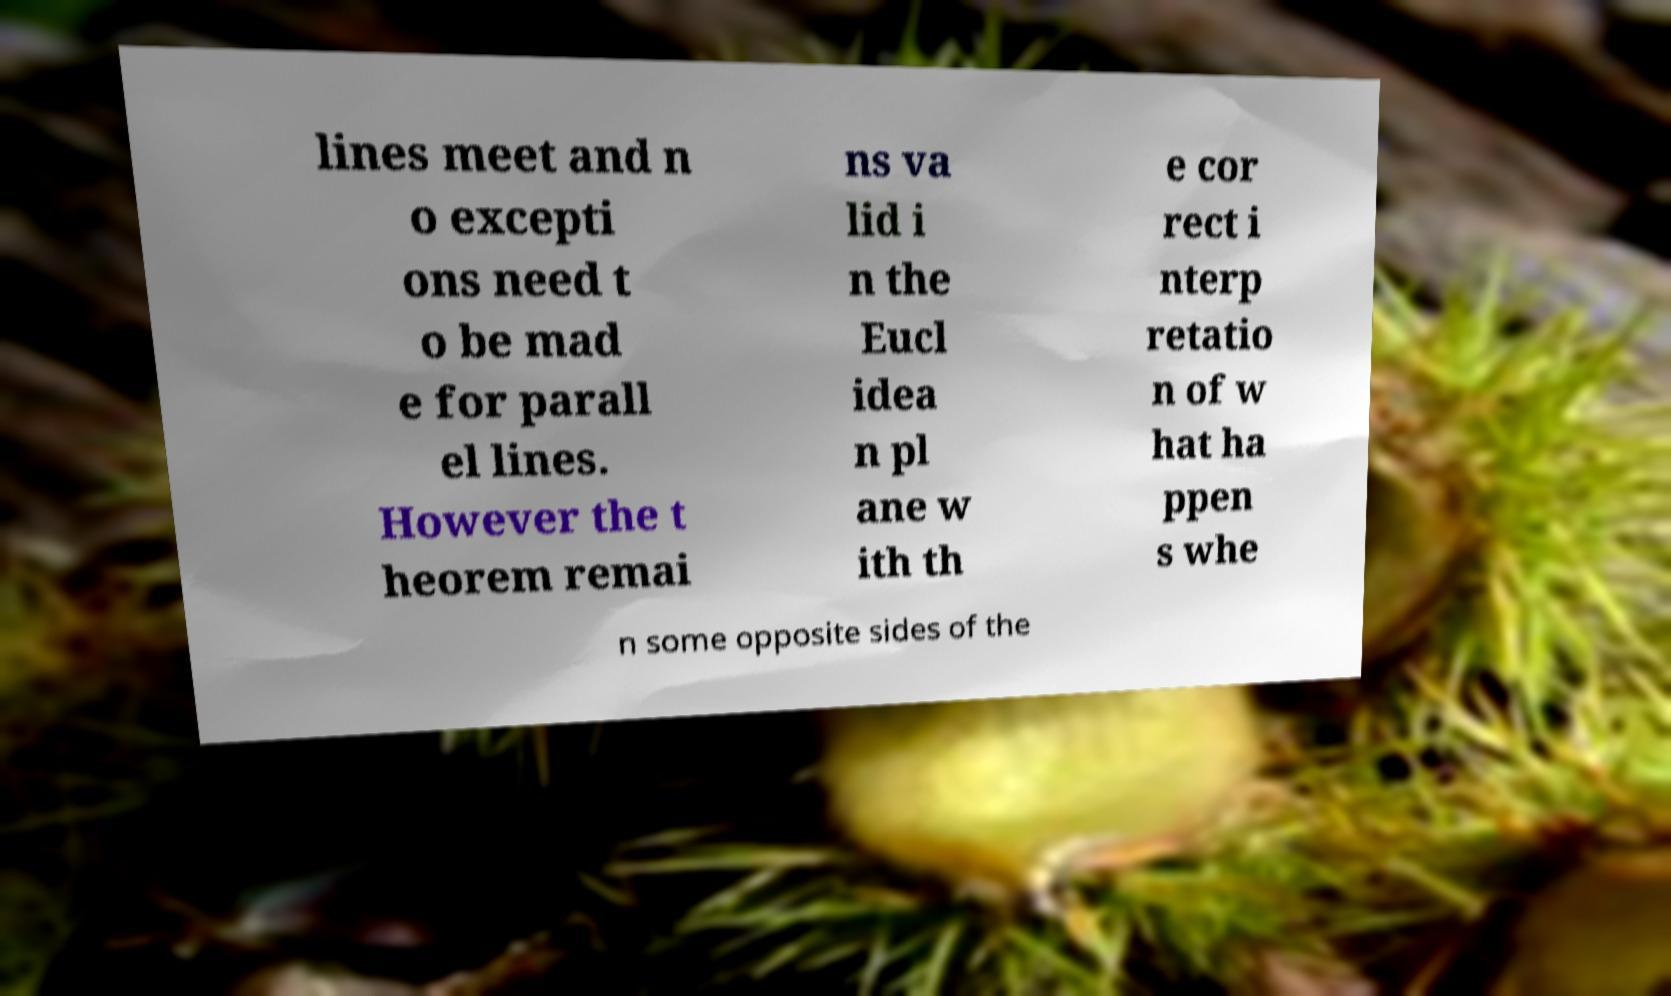Could you assist in decoding the text presented in this image and type it out clearly? lines meet and n o excepti ons need t o be mad e for parall el lines. However the t heorem remai ns va lid i n the Eucl idea n pl ane w ith th e cor rect i nterp retatio n of w hat ha ppen s whe n some opposite sides of the 